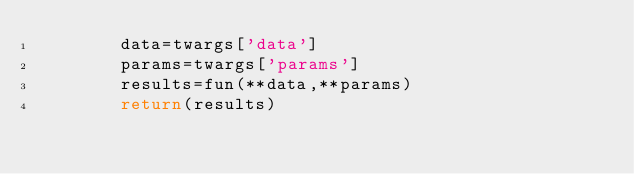<code> <loc_0><loc_0><loc_500><loc_500><_Python_>        data=twargs['data']
        params=twargs['params']
        results=fun(**data,**params)
        return(results)   
</code> 